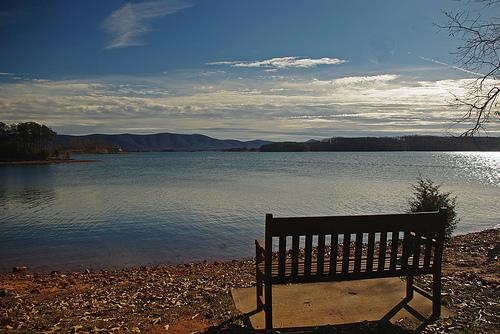Describe the landscape of the image as seen by a person sitting on the wooden bench. As you sit on the wooden bench, you gaze upon the serene water reflecting the sky and trees, the cloud-dotted blue horizon, and the gentle mountains that stand silently in the distance. Create a nostalgic description of the scene in the image. An old, wooden bench sits on the shore, inviting one to rest and take in the timeless beauty of serene waters, white clouds dancing in the sky, and distant mountains whispering ancient tales. Create a poetic description of the image's main elements. An empty wooden bench rests on the shore, facing the tranquil waters that mirror tree reflections; leaves scattered around, with mountains and cloud-filled skies as a silent backdrop. Describe the image as if you were writing an opening paragraph of a novel. On the edge of a peaceful lake stood a wooden bench, forever watching the still waters, the leafless trees, and the majestic mountains in the distance. As the sun hid behind the clouds, its rays caressed the water, painting golden reflections of the world above. Mention three objects in the image and describe how they are positioned. There is a wooden bench with armrests on the shore, facing the large body of calm water, next to a short green shrub and a cement pad underneath. Create an advertisement description for this image for a relaxation app. Escape into tranquility with this idyllic scene of an empty wooden bench by the shore, facing a calm lake, surrounded by majestic mountains, skies painted with white clouds, and soothing reflections dancing on the water's surface. Describe the image in a way that highlights its beauty and serenity for a travel brochure. Discover a majestic landscape where an empty wooden bench sits on the shore, overlooking tranquil waters, with a stunning background of mountains and skies adorned with white clouds, offering a moment of peaceful solitude amidst nature's wonders. Mention two objects that interact with each other in the image. The sun, hidden behind the clouds, casts a reflection on the calm water surface. Mention the most prominent feature of the image and describe its surroundings. There is a wooden bench on the shore with a peaceful view of smooth water, mountains in the background, white clouds in the sky, and trees growing in the distance. Describe the atmosphere in the image and mention two visual elements contributing to it. The image has a serene and peaceful atmosphere, created by the smooth water and the backdrop of mountains and white clouds in the blue sky. 